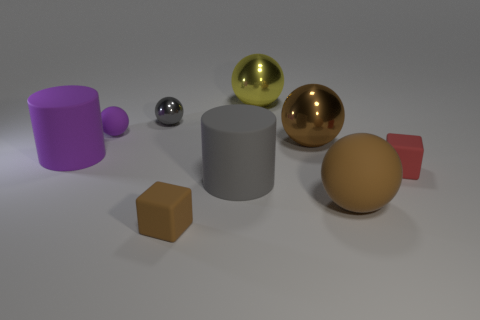How many blue metallic objects are the same shape as the small gray shiny object? Based on the image provided, there are no blue metallic objects that share the same shape as the small gray shiny object, which appears to be a sphere. 